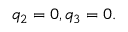Convert formula to latex. <formula><loc_0><loc_0><loc_500><loc_500>q _ { 2 } = 0 , q _ { 3 } = 0 .</formula> 